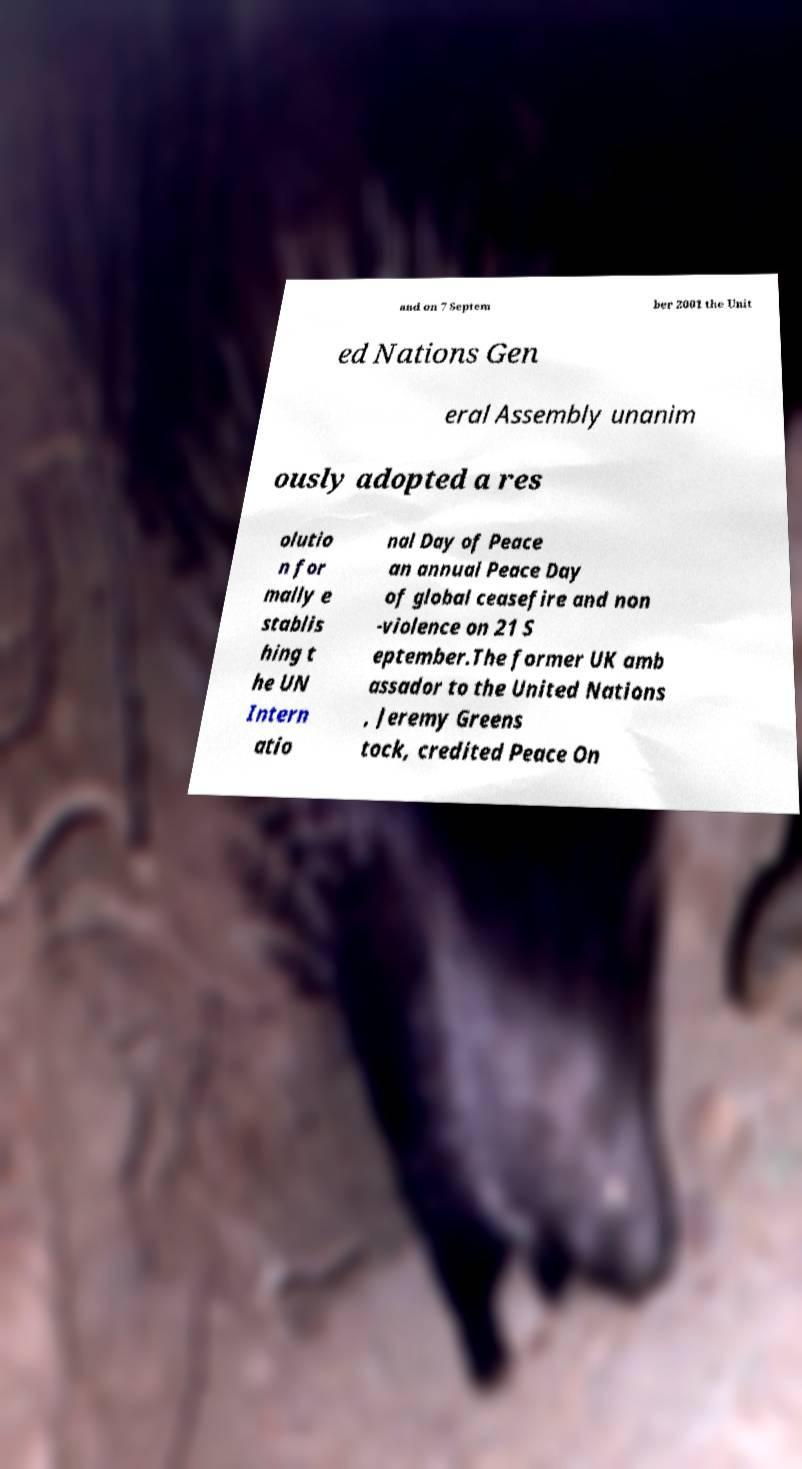Please identify and transcribe the text found in this image. and on 7 Septem ber 2001 the Unit ed Nations Gen eral Assembly unanim ously adopted a res olutio n for mally e stablis hing t he UN Intern atio nal Day of Peace an annual Peace Day of global ceasefire and non -violence on 21 S eptember.The former UK amb assador to the United Nations , Jeremy Greens tock, credited Peace On 